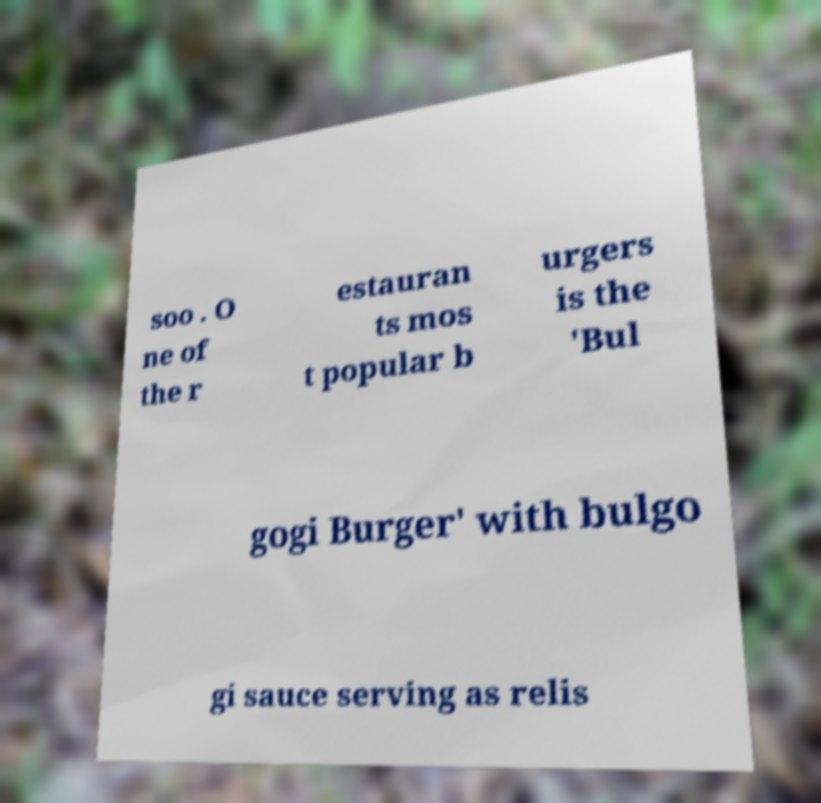Could you extract and type out the text from this image? soo . O ne of the r estauran ts mos t popular b urgers is the 'Bul gogi Burger' with bulgo gi sauce serving as relis 